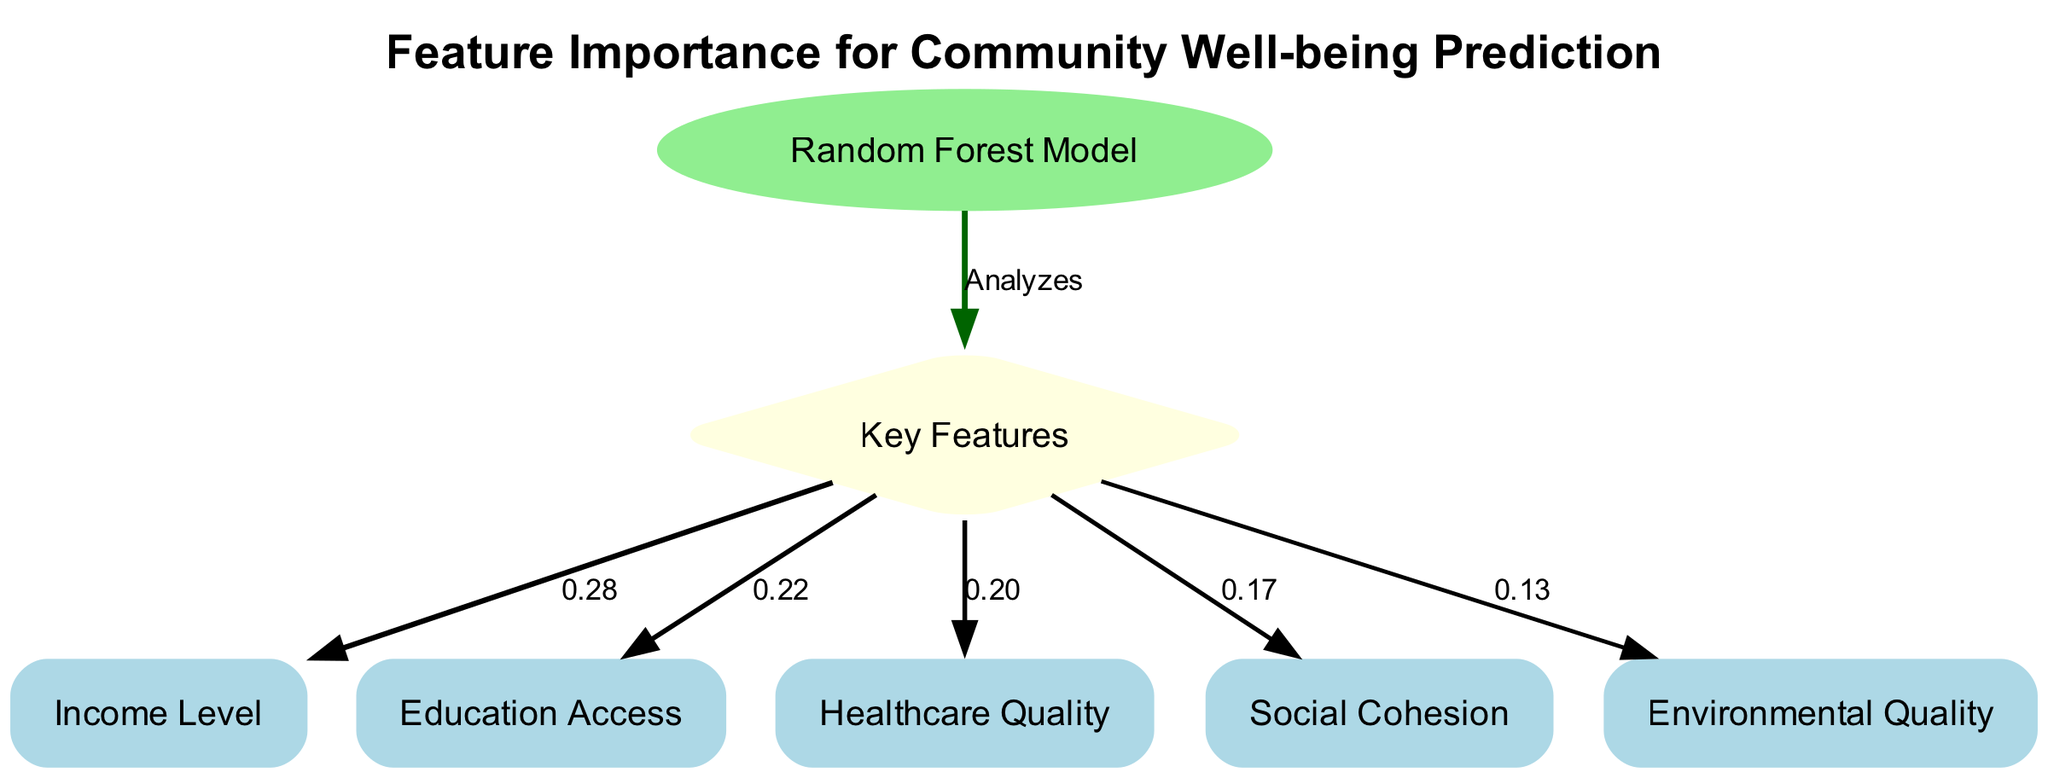What is the main model used in this diagram? The diagram identifies "Random Forest Model" as the primary model analyzing the features related to community well-being. This can be directly obtained from the node labeled "Random Forest Model."
Answer: Random Forest Model How many key features are presented in the diagram? The diagram lists five key features. This can be determined by counting the nodes labeled as features which are connected to the "features" node.
Answer: 5 Which feature has the highest importance value? The feature "Income Level" has the highest importance value of 0.28. This is determined by looking at the values connected to the "features" node, where "Income Level" has the largest number among others.
Answer: Income Level What is the importance value of "Healthcare Quality"? The importance value of "Healthcare Quality" is 0.20. This can be found by looking at the edge connecting "Healthcare Quality" to the "features" node and reading the associated value.
Answer: 0.20 What is the label of the node that represents features? The node representing features is labeled "Key Features." This is identifiable from the labeled node linked directly to the Random Forest Model.
Answer: Key Features How do "Social Cohesion" and "Environmental Quality" compare in importance? "Social Cohesion" has an importance value of 0.17 while "Environmental Quality" has 0.13. Thus "Social Cohesion" is more important than "Environmental Quality." This comparison is based on the values associated with both features connected to the "features" node.
Answer: Social Cohesion is more important What connects the "Random Forest Model" to the "Key Features"? The two nodes are connected by an edge labeled "Analyzes," indicating the model's role in analyzing the features that predict community well-being. This is directly noted in the edge connecting the "model" to the "features."
Answer: Analyzes Which feature has the lowest importance score? The feature "Environmental Quality" has the lowest importance score of 0.13. This can be ascertained by comparing the importance values of all feature nodes connected to the "features" node.
Answer: Environmental Quality What type of diagram is represented here? This diagram is a "Machine Learning Diagram." The structure and content indicate a focus on feature importance in predicting outcomes using a machine learning approach.
Answer: Machine Learning Diagram 